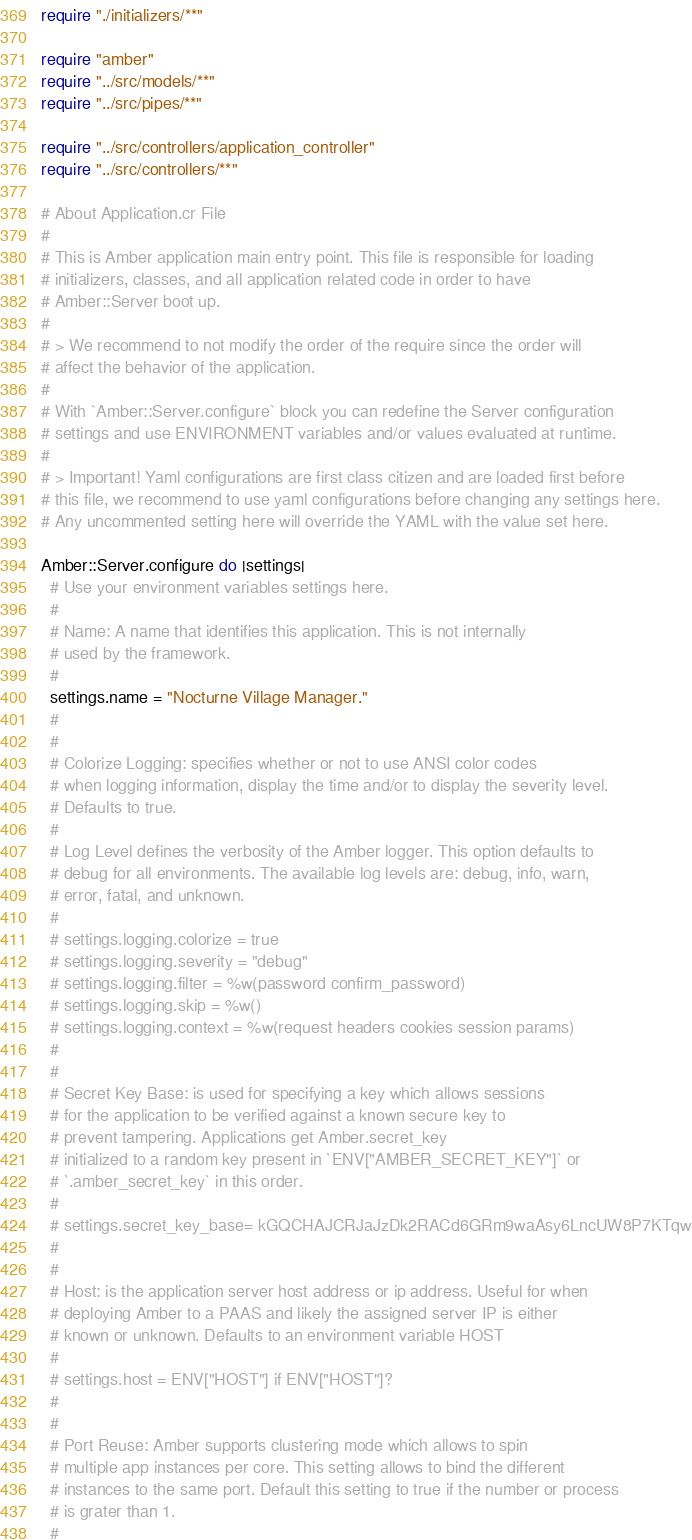Convert code to text. <code><loc_0><loc_0><loc_500><loc_500><_Crystal_>require "./initializers/**"

require "amber"
require "../src/models/**"
require "../src/pipes/**"

require "../src/controllers/application_controller"
require "../src/controllers/**"

# About Application.cr File
#
# This is Amber application main entry point. This file is responsible for loading
# initializers, classes, and all application related code in order to have
# Amber::Server boot up.
#
# > We recommend to not modify the order of the require since the order will
# affect the behavior of the application.
#
# With `Amber::Server.configure` block you can redefine the Server configuration
# settings and use ENVIRONMENT variables and/or values evaluated at runtime.
#
# > Important! Yaml configurations are first class citizen and are loaded first before
# this file, we recommend to use yaml configurations before changing any settings here.
# Any uncommented setting here will override the YAML with the value set here.

Amber::Server.configure do |settings|
  # Use your environment variables settings here.
  #
  # Name: A name that identifies this application. This is not internally
  # used by the framework.
  #
  settings.name = "Nocturne Village Manager."
  #
  #
  # Colorize Logging: specifies whether or not to use ANSI color codes
  # when logging information, display the time and/or to display the severity level.
  # Defaults to true.
  #
  # Log Level defines the verbosity of the Amber logger. This option defaults to
  # debug for all environments. The available log levels are: debug, info, warn,
  # error, fatal, and unknown.
  #
  # settings.logging.colorize = true
  # settings.logging.severity = "debug"
  # settings.logging.filter = %w(password confirm_password)
  # settings.logging.skip = %w()
  # settings.logging.context = %w(request headers cookies session params)
  #
  #
  # Secret Key Base: is used for specifying a key which allows sessions
  # for the application to be verified against a known secure key to
  # prevent tampering. Applications get Amber.secret_key
  # initialized to a random key present in `ENV["AMBER_SECRET_KEY"]` or
  # `.amber_secret_key` in this order.
  #
  # settings.secret_key_base= kGQCHAJCRJaJzDk2RACd6GRm9waAsy6LncUW8P7KTqw
  #
  #
  # Host: is the application server host address or ip address. Useful for when
  # deploying Amber to a PAAS and likely the assigned server IP is either
  # known or unknown. Defaults to an environment variable HOST
  #
  # settings.host = ENV["HOST"] if ENV["HOST"]?
  #
  #
  # Port Reuse: Amber supports clustering mode which allows to spin
  # multiple app instances per core. This setting allows to bind the different
  # instances to the same port. Default this setting to true if the number or process
  # is grater than 1.
  #</code> 